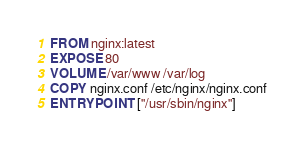Convert code to text. <code><loc_0><loc_0><loc_500><loc_500><_Dockerfile_>FROM nginx:latest
EXPOSE 80
VOLUME /var/www /var/log
COPY nginx.conf /etc/nginx/nginx.conf
ENTRYPOINT ["/usr/sbin/nginx"]</code> 